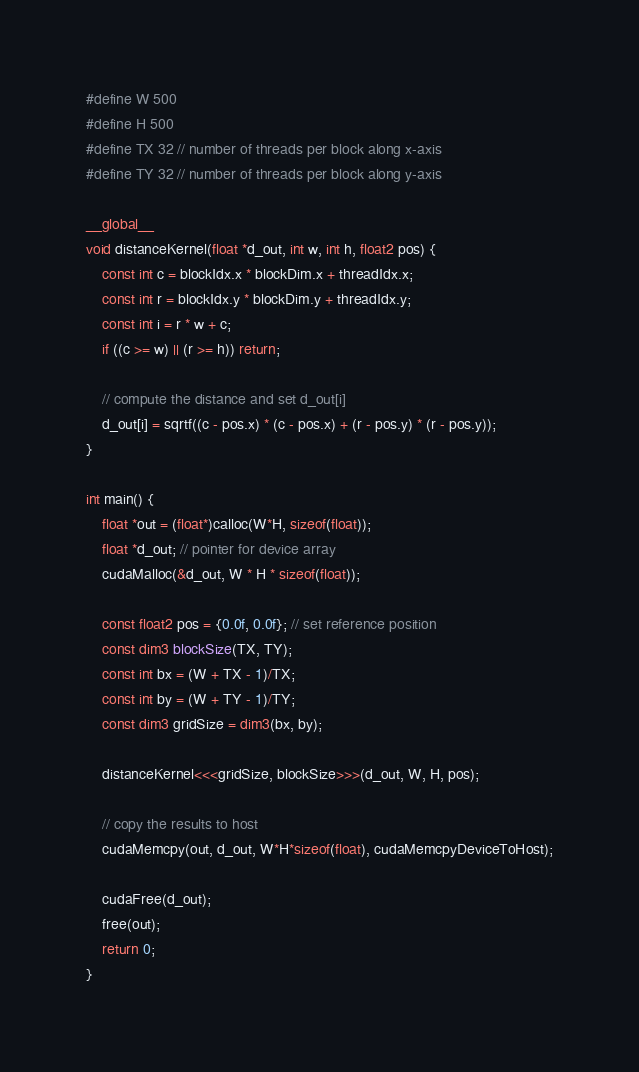Convert code to text. <code><loc_0><loc_0><loc_500><loc_500><_Cuda_>#define W 500
#define H 500
#define TX 32 // number of threads per block along x-axis
#define TY 32 // number of threads per block along y-axis

__global__
void distanceKernel(float *d_out, int w, int h, float2 pos) {
    const int c = blockIdx.x * blockDim.x + threadIdx.x;
    const int r = blockIdx.y * blockDim.y + threadIdx.y;
    const int i = r * w + c;
    if ((c >= w) || (r >= h)) return;

    // compute the distance and set d_out[i]
    d_out[i] = sqrtf((c - pos.x) * (c - pos.x) + (r - pos.y) * (r - pos.y));
}

int main() {
    float *out = (float*)calloc(W*H, sizeof(float));
    float *d_out; // pointer for device array
    cudaMalloc(&d_out, W * H * sizeof(float));

    const float2 pos = {0.0f, 0.0f}; // set reference position
    const dim3 blockSize(TX, TY);
    const int bx = (W + TX - 1)/TX;
    const int by = (W + TY - 1)/TY;
    const dim3 gridSize = dim3(bx, by);

    distanceKernel<<<gridSize, blockSize>>>(d_out, W, H, pos);

    // copy the results to host
    cudaMemcpy(out, d_out, W*H*sizeof(float), cudaMemcpyDeviceToHost);

    cudaFree(d_out);
    free(out);
    return 0;
}
</code> 